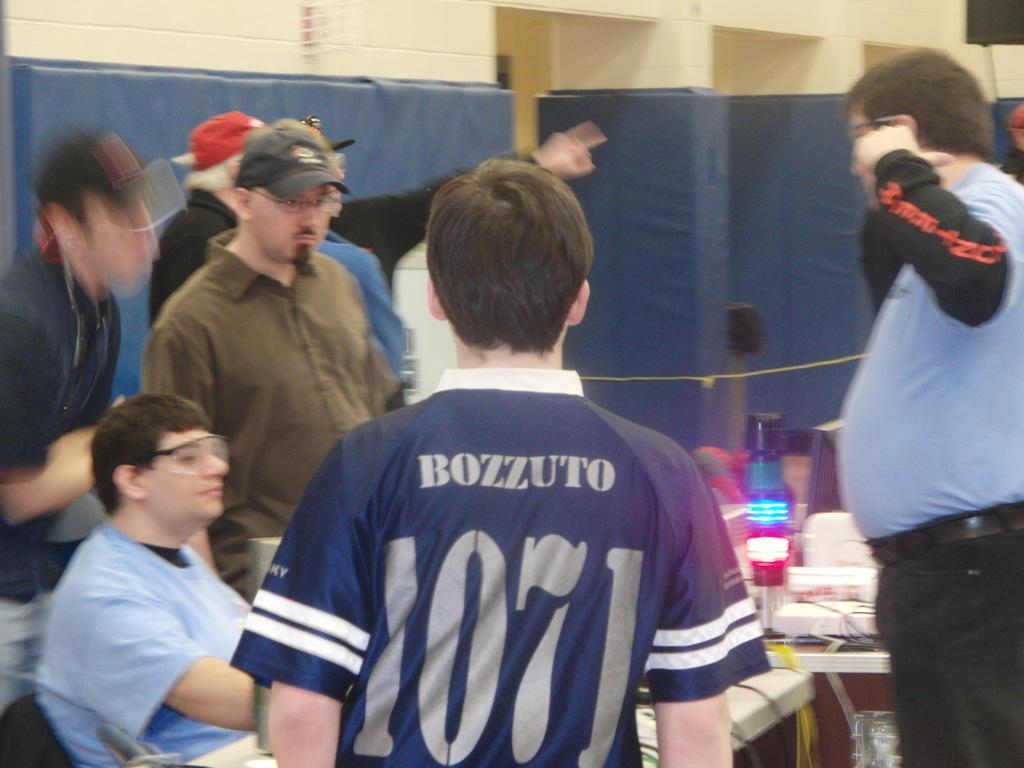<image>
Create a compact narrative representing the image presented. A guy has the word Bozzuto on the back of his shirt. 